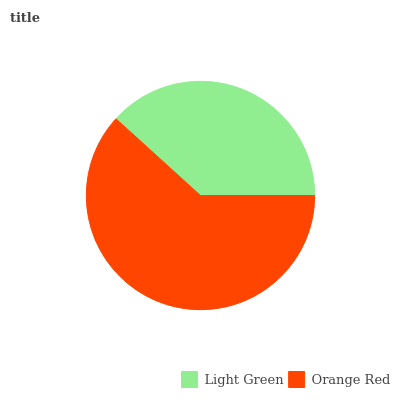Is Light Green the minimum?
Answer yes or no. Yes. Is Orange Red the maximum?
Answer yes or no. Yes. Is Orange Red the minimum?
Answer yes or no. No. Is Orange Red greater than Light Green?
Answer yes or no. Yes. Is Light Green less than Orange Red?
Answer yes or no. Yes. Is Light Green greater than Orange Red?
Answer yes or no. No. Is Orange Red less than Light Green?
Answer yes or no. No. Is Orange Red the high median?
Answer yes or no. Yes. Is Light Green the low median?
Answer yes or no. Yes. Is Light Green the high median?
Answer yes or no. No. Is Orange Red the low median?
Answer yes or no. No. 